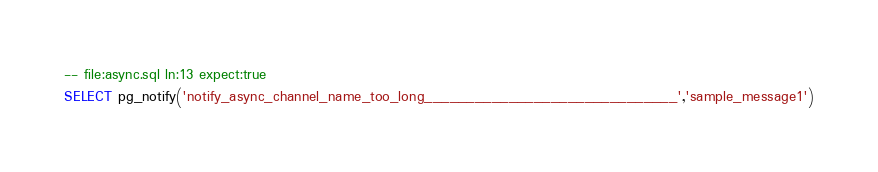Convert code to text. <code><loc_0><loc_0><loc_500><loc_500><_SQL_>-- file:async.sql ln:13 expect:true
SELECT pg_notify('notify_async_channel_name_too_long______________________________','sample_message1')
</code> 